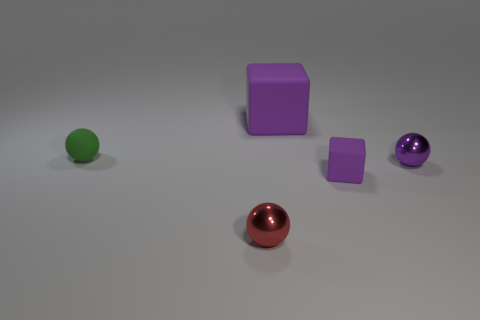Are there any purple rubber objects that have the same size as the purple shiny sphere?
Give a very brief answer. Yes. There is a purple thing that is made of the same material as the tiny purple cube; what is its size?
Your answer should be compact. Large. There is a big matte object; what shape is it?
Offer a very short reply. Cube. Is the green object made of the same material as the purple ball behind the red shiny ball?
Provide a succinct answer. No. How many things are either small blocks or tiny red metal things?
Provide a short and direct response. 2. Are there any big purple matte blocks?
Your response must be concise. Yes. What shape is the tiny object left of the small shiny sphere on the left side of the big cube?
Your response must be concise. Sphere. What number of things are either objects that are behind the small purple metal object or things that are behind the tiny red metal sphere?
Your response must be concise. 4. What is the material of the red object that is the same size as the green matte object?
Ensure brevity in your answer.  Metal. What is the color of the big matte block?
Your response must be concise. Purple. 